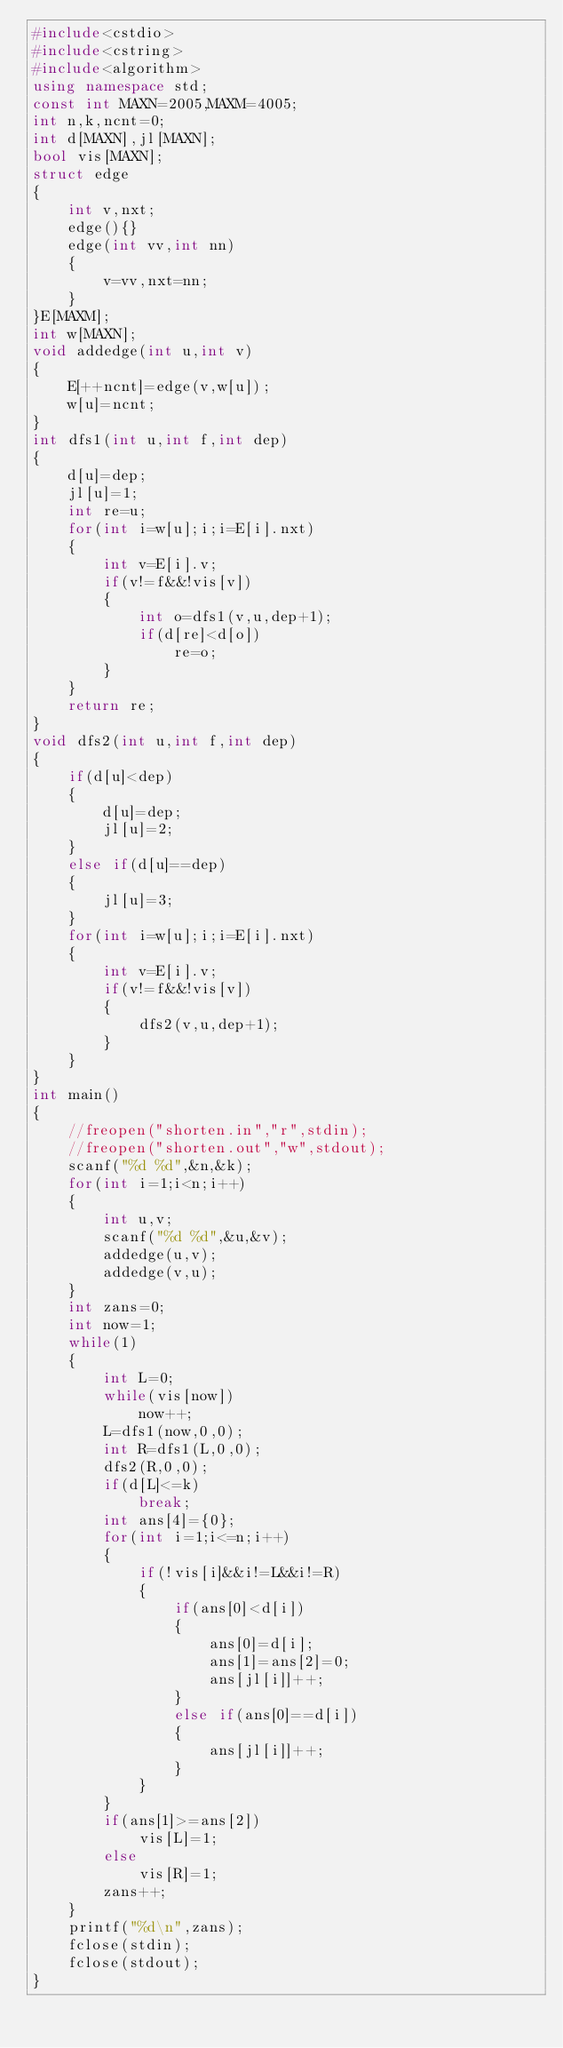<code> <loc_0><loc_0><loc_500><loc_500><_C++_>#include<cstdio>
#include<cstring>
#include<algorithm>
using namespace std;
const int MAXN=2005,MAXM=4005;
int n,k,ncnt=0;
int d[MAXN],jl[MAXN];
bool vis[MAXN];
struct edge
{
	int v,nxt;
	edge(){}
	edge(int vv,int nn)
	{
		v=vv,nxt=nn;
	}
}E[MAXM];
int w[MAXN];
void addedge(int u,int v)
{
	E[++ncnt]=edge(v,w[u]);
	w[u]=ncnt;
}
int dfs1(int u,int f,int dep)
{
	d[u]=dep;
	jl[u]=1;
	int re=u;
	for(int i=w[u];i;i=E[i].nxt)
	{
		int v=E[i].v;
		if(v!=f&&!vis[v])
		{
			int o=dfs1(v,u,dep+1);
			if(d[re]<d[o])
				re=o;
		}
	}
	return re;
}
void dfs2(int u,int f,int dep)
{
	if(d[u]<dep)
	{
		d[u]=dep;
		jl[u]=2;
	}
	else if(d[u]==dep)
	{
		jl[u]=3;
	}
	for(int i=w[u];i;i=E[i].nxt)
	{
		int v=E[i].v;
		if(v!=f&&!vis[v])
		{
			dfs2(v,u,dep+1);
		}
	}
}
int main()
{
	//freopen("shorten.in","r",stdin);
	//freopen("shorten.out","w",stdout);
	scanf("%d %d",&n,&k);
	for(int i=1;i<n;i++)
	{
		int u,v;
		scanf("%d %d",&u,&v);
		addedge(u,v);
		addedge(v,u);
	}
	int zans=0;
	int now=1;
	while(1)
	{
		int L=0;
		while(vis[now])
			now++;
		L=dfs1(now,0,0);
		int R=dfs1(L,0,0);
		dfs2(R,0,0);
		if(d[L]<=k)
			break;
		int ans[4]={0};
		for(int i=1;i<=n;i++)
		{
			if(!vis[i]&&i!=L&&i!=R)
			{
				if(ans[0]<d[i])
				{
					ans[0]=d[i];
					ans[1]=ans[2]=0;
					ans[jl[i]]++;
				}
				else if(ans[0]==d[i])
				{
					ans[jl[i]]++;
				}
			}
		}
		if(ans[1]>=ans[2])
			vis[L]=1;
		else
			vis[R]=1;
		zans++;
	}
	printf("%d\n",zans);
	fclose(stdin);
	fclose(stdout);
}</code> 